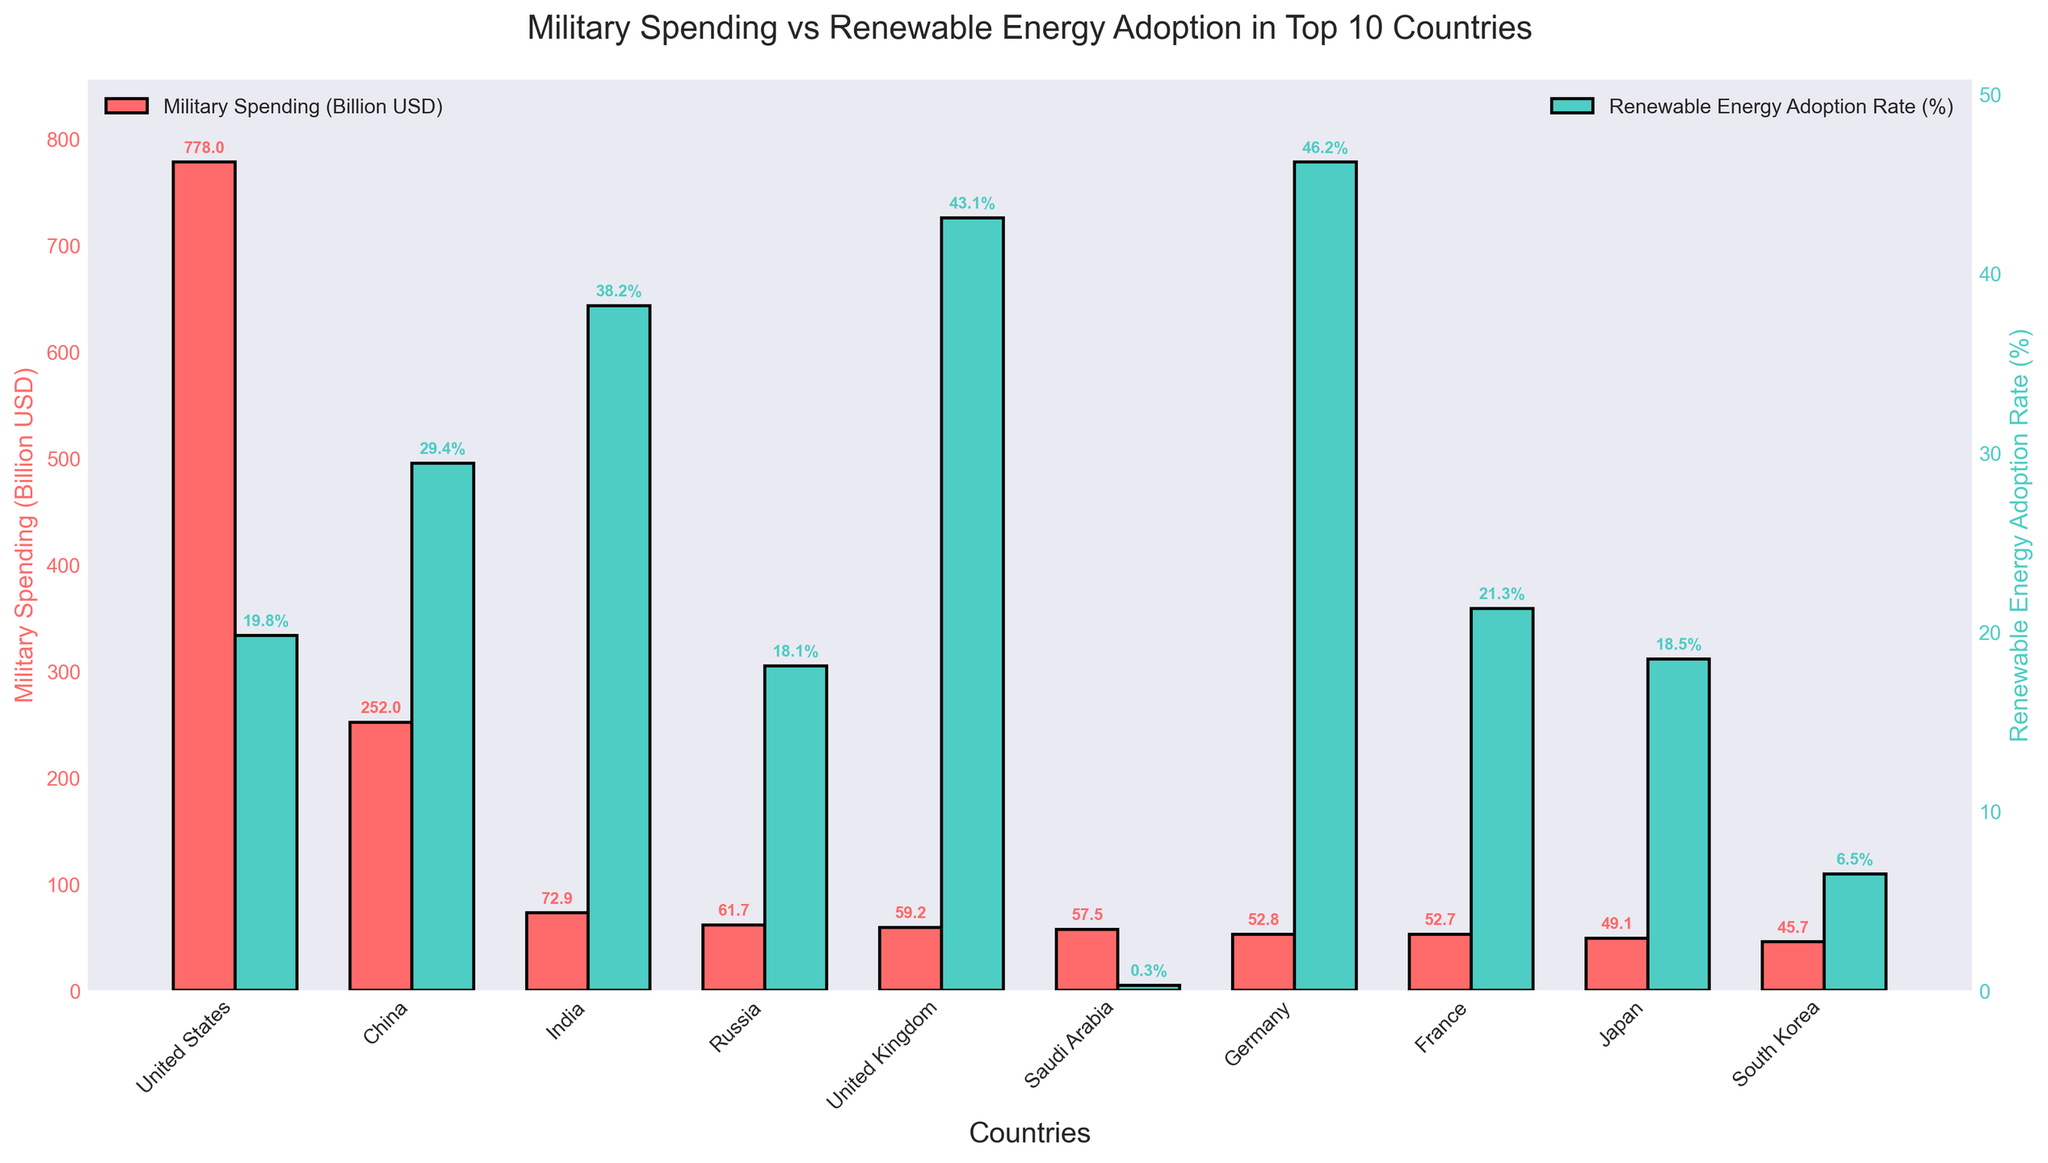Which country has the highest military spending? From the figure, the United States has the tallest red bar, which represents the highest military spending among the listed countries.
Answer: United States Which country has the highest renewable energy adoption rate among the top 10 military spenders? The figure shows the tallest green bar, which corresponds to Germany’s renewable energy adoption rate of 46.2%.
Answer: Germany How does China’s renewable energy adoption rate compare to that of the United States? China's green bar (29.4%) is higher compared to the United States' green bar (19.8%), indicating that China has a higher renewable energy adoption rate.
Answer: China has a higher rate What is the combined military spending of Russia and Saudi Arabia? From the figure, Russia’s military spending is 61.7 billion USD and Saudi Arabia’s is 57.5 billion USD. Adding these gives 61.7 + 57.5 = 119.2 billion USD.
Answer: 119.2 billion USD Which country among the top 10 has the lowest renewable energy adoption rate, and what is that rate? The shortest green bar among the top 10 corresponds to Saudi Arabia, with a renewable energy adoption rate of 0.3%.
Answer: Saudi Arabia, 0.3% Is there any country in the top 10 that spends less than 50 billion USD on the military but has more than a 40% renewable energy adoption rate? Yes, the figure shows that the United Kingdom meets this criterion with a military spending of 59.2 billion USD and a renewable energy adoption rate of 43.1%.
Answer: United Kingdom How much more is the United States' military spending compared to Japan's? The figure shows that the United States’ military spending is 778 billion USD and Japan’s is 49.1 billion USD. The difference is 778 - 49.1 = 728.9 billion USD.
Answer: 728.9 billion USD What is the average renewable energy adoption rate among the top 10 countries by military spending? Summing up the renewable energy adoption rates for the top 10 countries and dividing by 10: (19.8 + 29.4 + 38.2 + 18.1 + 43.1 + 0.3 + 46.2 + 21.3 + 18.5 + 6.5) / 10 = 24.14%
Answer: 24.14% Which countries have higher renewable energy adoption rates than military spending (as billions of USD)? Comparing bars for each country reveals that no country among the top 10 has a higher renewable energy adoption rate than its military spending, given all military spending values are above 19.2 which is higher than any adoption rates above 50%.
Answer: None 